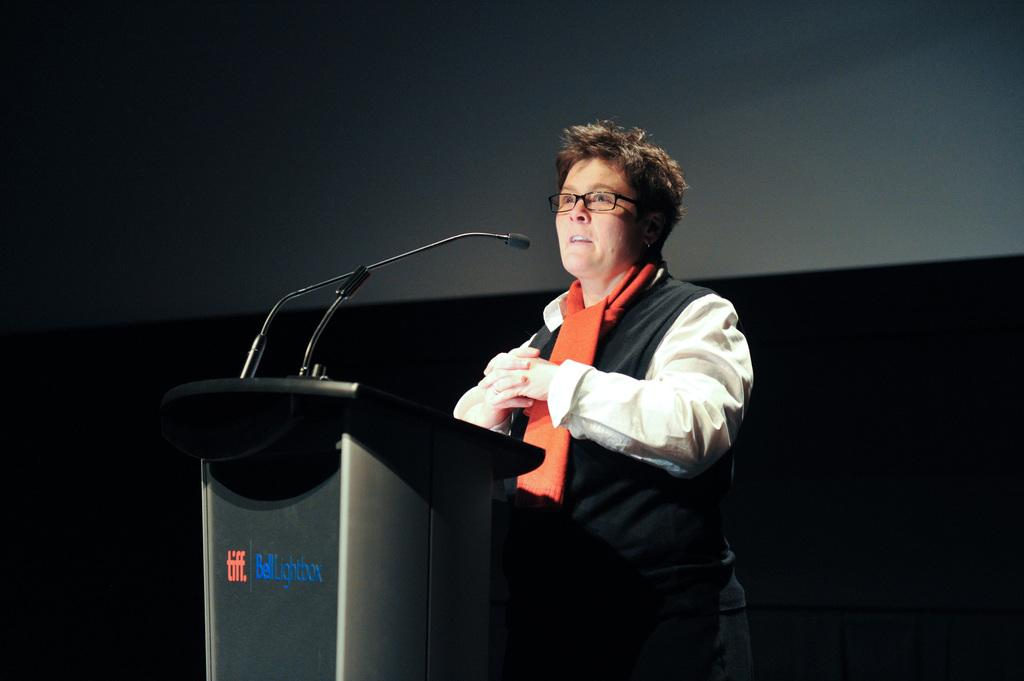What is the main subject of the image? There is a person standing in the center of the image. Can you describe the person's appearance? The person is wearing glasses and a scarf. What is located near the person in the image? There is a podium with a mic stand in the image. What can be seen in the background of the image? There is a wall in the background of the image. How many bears are visible in the image? There are no bears present in the image. What company is sponsoring the event in the image? There is no indication of a company sponsoring an event in the image. 